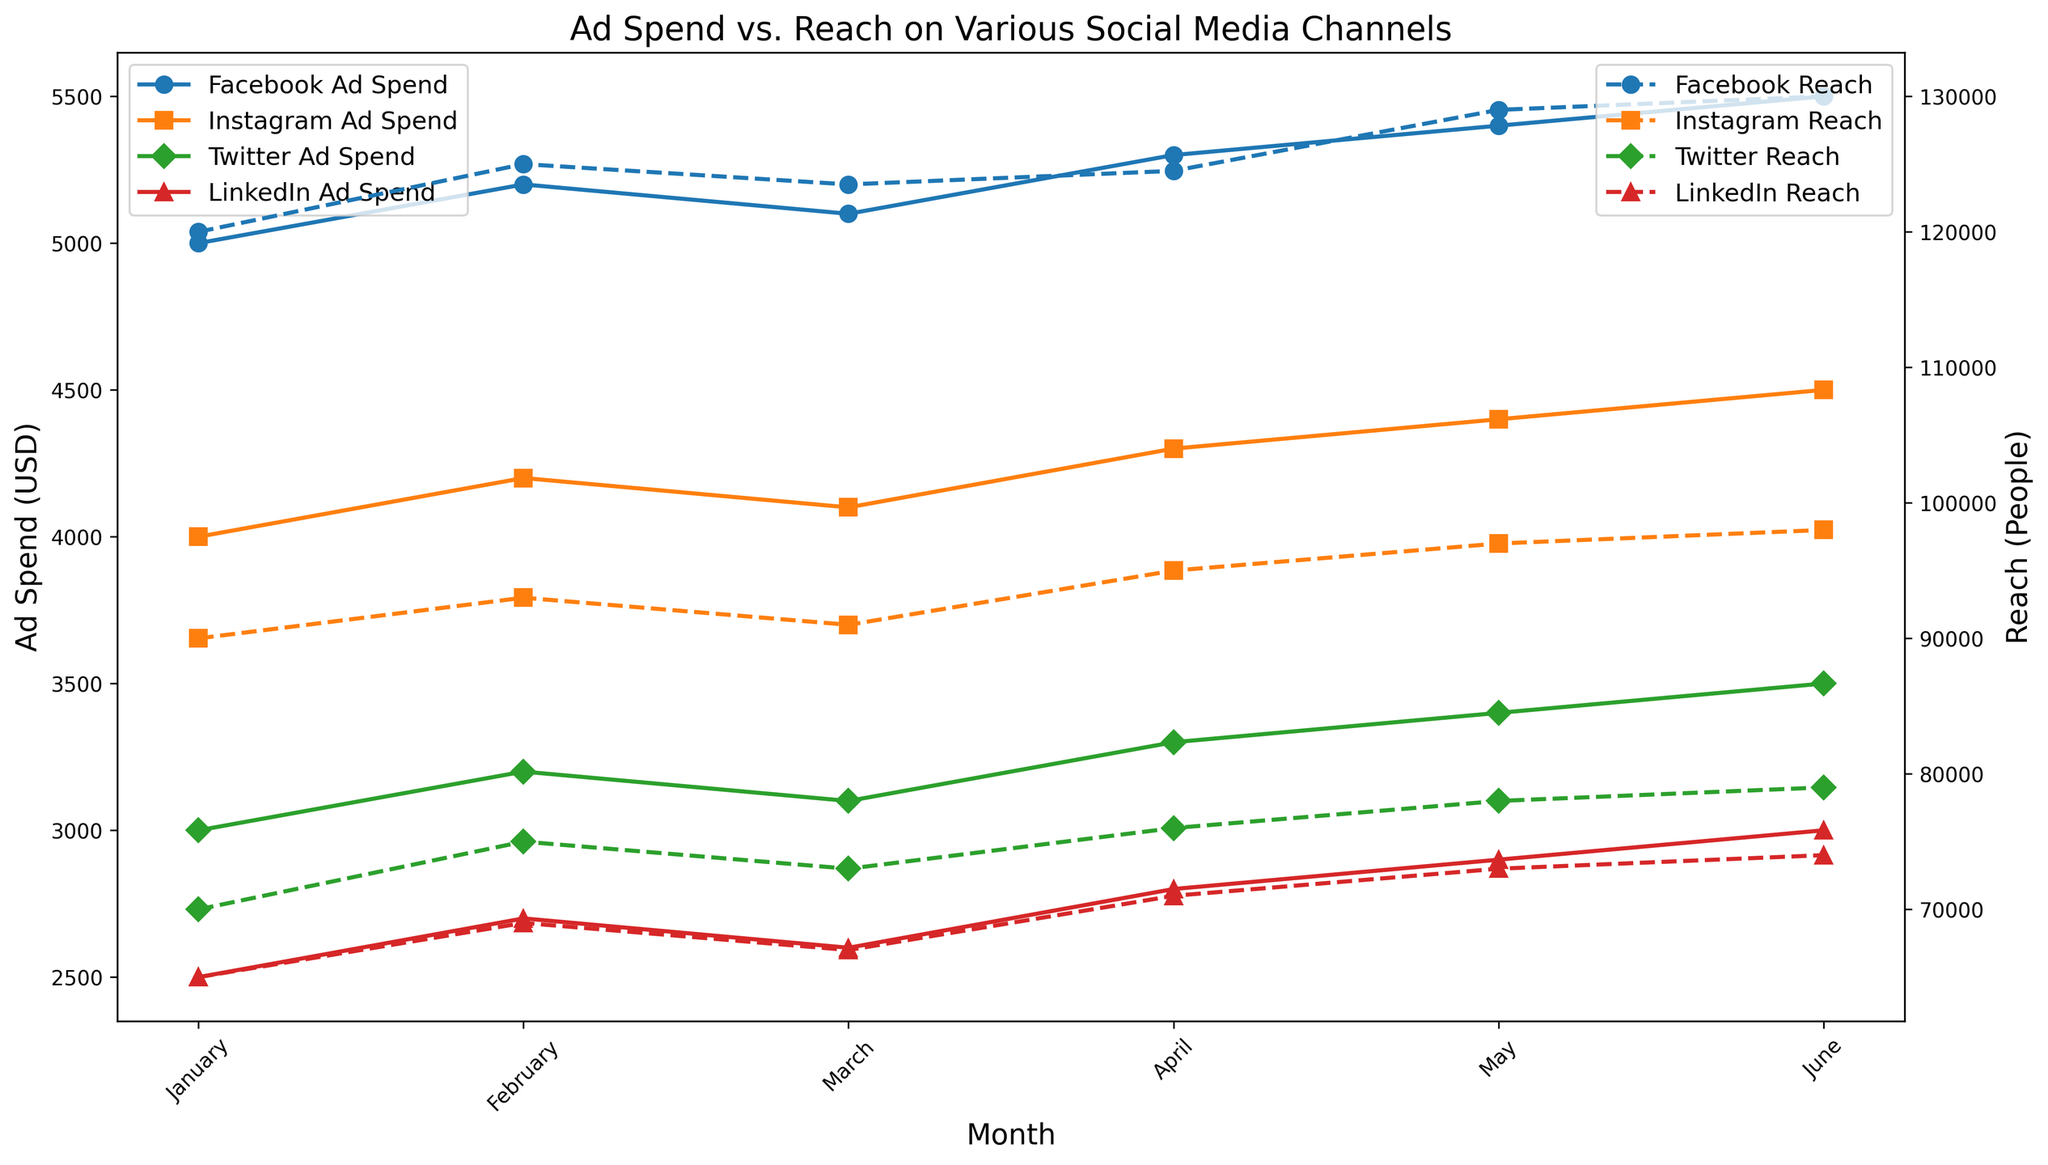Which social media channel had the highest ad spend in June? To find the answer, look at the line plots of Ad Spend for the month of June and identify the highest point among the channels. Facebook has an ad spend of $5500, Instagram $4500, Twitter $3500, and LinkedIn $3000. Facebook has the highest spend.
Answer: Facebook Which month saw the highest increase in reach for Instagram compared to the previous month? Compare the reach of Instagram for each consecutive month and determine the month with the highest increase. The differences are February (+3000), March (-2000), April (+4000), May (+2000), and June (+1000). April to May has the highest increase of +4000.
Answer: April What is the total ad spend for Facebook over the six months? Add the ad spends for Facebook from January to June: 5000 + 5200 + 5100 + 5300 + 5400 + 5500. The total is 31500.
Answer: 31500 Compare the average reach per month between Twitter and LinkedIn. Which one is higher? Calculate the average reach per month for both channels: Twitter: (70000 + 75000 + 73000 + 76000 + 78000 + 79000) / 6 = 75166.67; LinkedIn: (65000 + 69000 + 67000 + 71000 + 73000 + 74000) / 6 = 69833.33. Twitter has a higher average reach.
Answer: Twitter Which two channels had the closest reach in March and what were their reach numbers? Examine the reach for all channels in March and identify the closest values: Facebook: 123500, Instagram: 91000, Twitter: 73000, LinkedIn: 67000. The closest reaches are Twitter and LinkedIn with 73000 and 67000, respectively.
Answer: Twitter and LinkedIn; 73000 and 67000 What month showed a decline in ad spend for Twitter compared to the previous month? Check the ad spend for Twitter each month and find the instances of decline: February (3200) to March (3100) is a decrease.
Answer: March Which channel had the steepest rise in ad spend from April to May? Compare the increases from April to May for all channels: Facebook (5300 to 5400), Instagram (4300 to 4400), Twitter (3300 to 3400), LinkedIn (2800 to 2900). All have a $100 increase, so there is no definitive steep rise.
Answer: None How does the reach of Facebook in May compare to its reach in January? Assess the reach of Facebook for both months: May (129000) vs. January (120000). The difference is 9000.
Answer: 9000 more Which channel and month had the highest reach overall? Identify the highest point in the reach values: Facebook in June with 130000 reach.
Answer: Facebook in June What is the average ad spend for Instagram over the six months? Calculate the average ad spend for Instagram: (4000 + 4200 + 4100 + 4300 + 4400 + 4500) / 6 = 4250.
Answer: 4250 